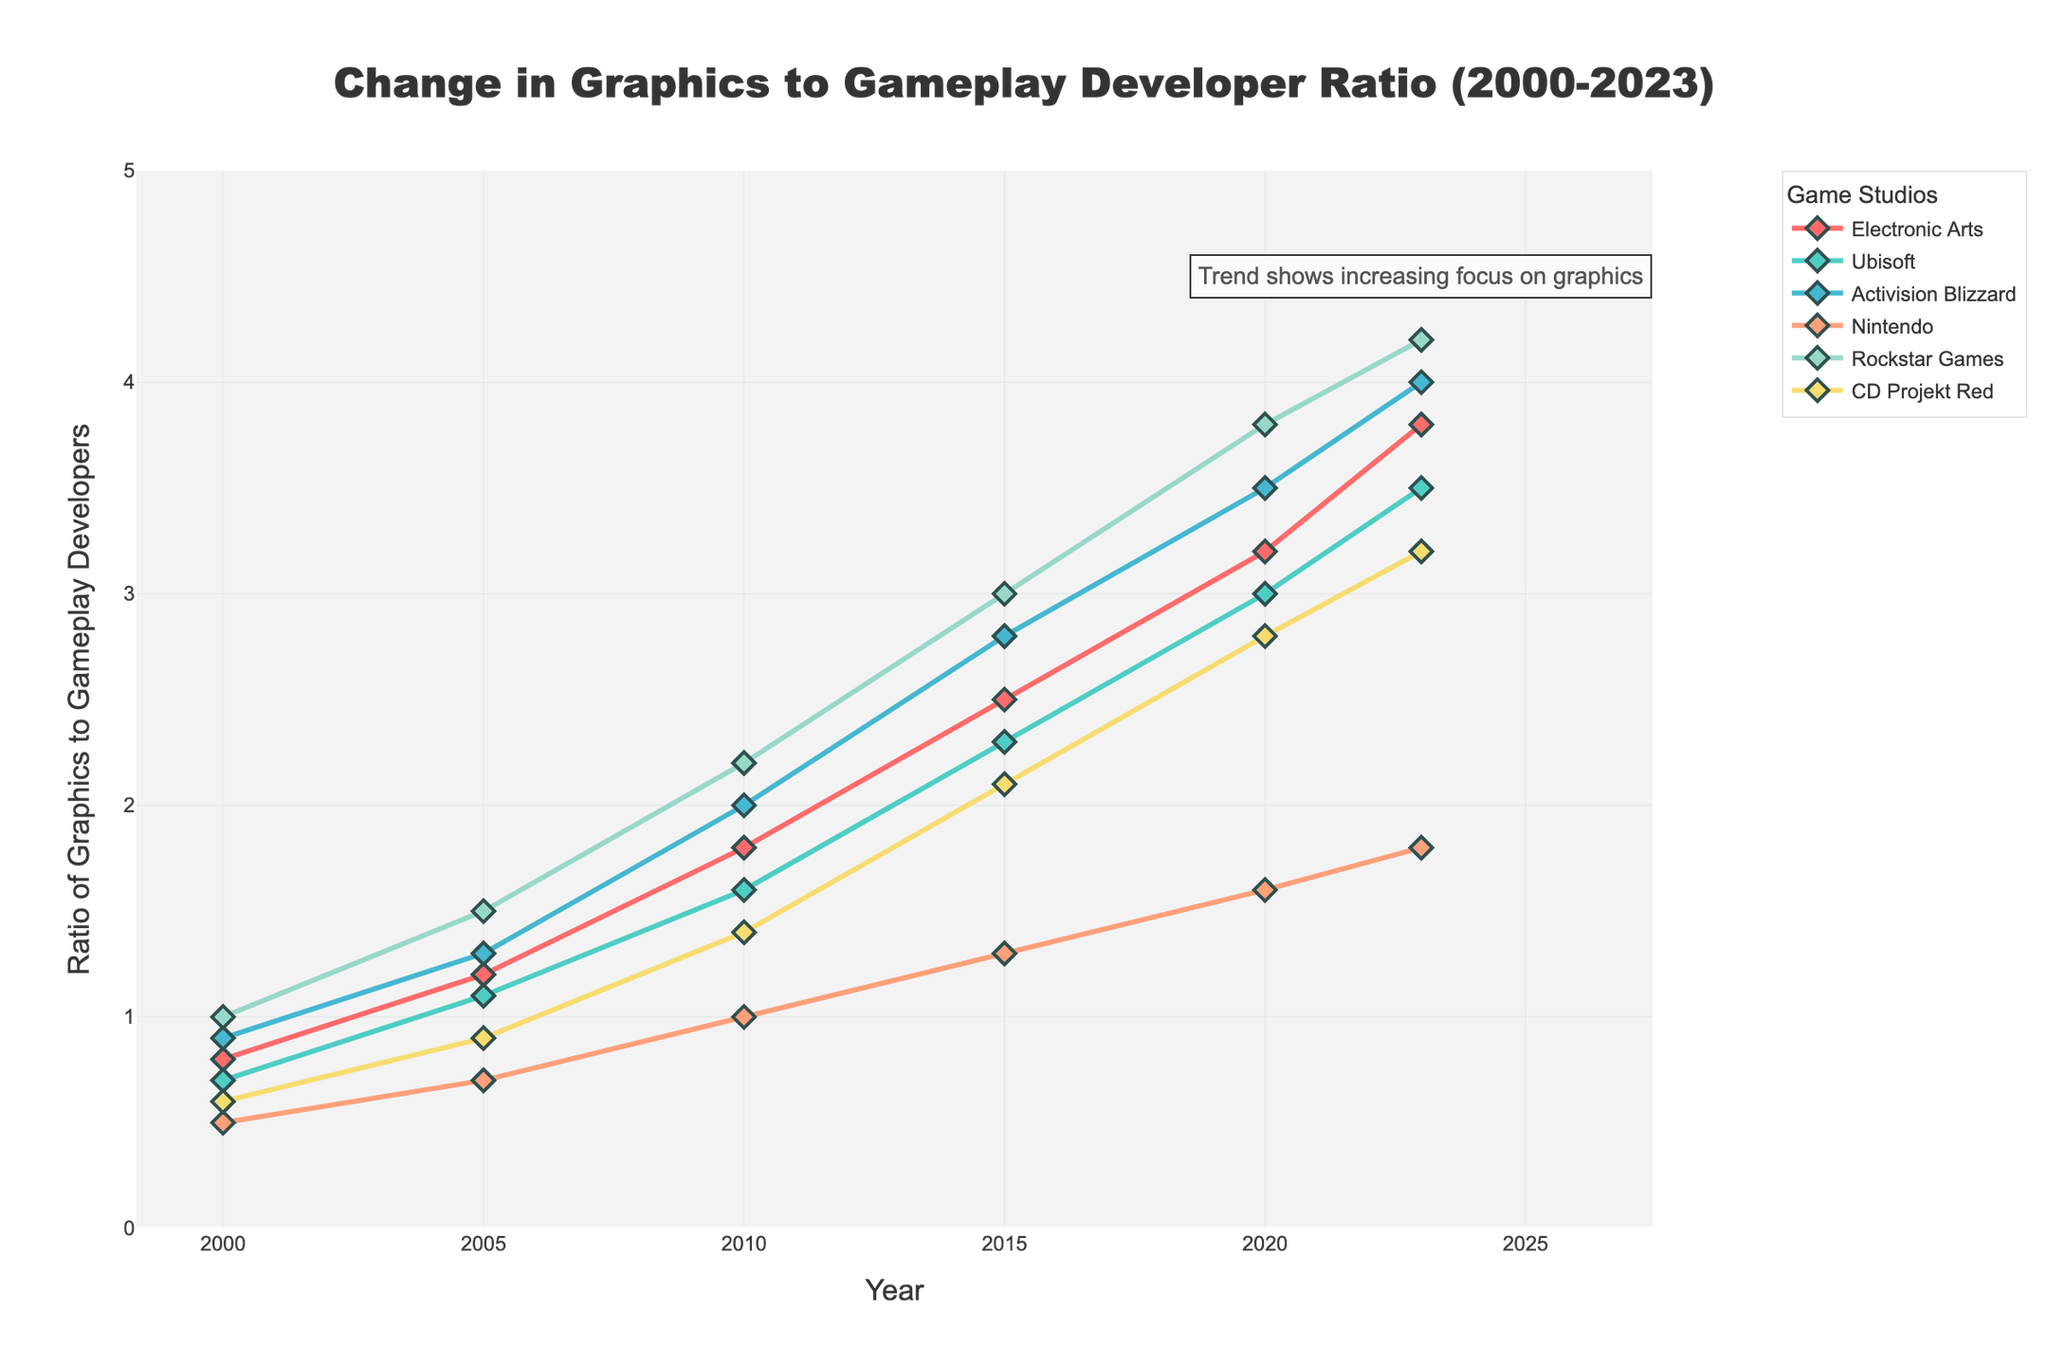What does the overall trend show about the ratio of graphics developers to gameplay programmers among all the game studios from 2000 to 2023? The overall trend indicates a steady increase in the ratio of graphics developers to gameplay programmers across all major game studios. Starting from relatively lower values in 2000, the ratios generally rise significantly over time, reaching the highest levels by 2023.
Answer: It shows a steady increase Which game studio had the highest ratio of graphics developers to gameplay programmers in 2023, and what was the ratio? By observing the topmost point in the year 2023, Rockstar Games had the highest ratio of graphics developers to gameplay programmers.
Answer: Rockstar Games; 4.2 How did Nintendo's ratio change from 2000 to 2023, and what does this reflect? By comparing the data points for Nintendo from 2000 (0.5) and 2023 (1.8), we see an increase of 1.3 in the ratio. This reflects a growing focus on graphics development over the 23 years.
Answer: Increased by 1.3 Between which two consecutive years did CD Projekt Red see the highest increase in its ratio of graphics developers to gameplay programmers? To identify this, we compare the differences between consecutive years: 2000-2005 (0.9-0.6=0.3), 2005-2010 (1.4-0.9=0.5), 2010-2015 (2.1-1.4=0.7), 2015-2020 (2.8-2.1=0.7), and 2020-2023 (3.2-2.8=0.4). The highest increase is between 2010 and 2015 and between 2015 and 2020, both with an increase of 0.7.
Answer: 2010-2015 and 2015-2020 Compare the ratio of graphics to gameplay developers for Ubisoft and Activision Blizzard in 2015 and indicate which company had the lower ratio. By looking at the data points for 2015, Ubisoft had a ratio of 2.3 and Activision Blizzard had a ratio of 2.8. Ubisoft had the lower ratio in 2015.
Answer: Ubisoft What can be inferred about the emphasis on graphics vs. gameplay in major game studios from the visual characteristics of the plot? The increasing trend lines for all studios and their upward trajectory visually indicate a growing emphasis on graphics over gameplay. The annotation also emphasizes this observation, stating, “Trend shows increasing focus on graphics.”
Answer: Growing emphasis on graphics If we average the ratio values from 2000 to 2023 for Electronic Arts, what is the average? The values for Electronic Arts from 2000 to 2023 are 0.8, 1.2, 1.8, 2.5, 3.2, and 3.8. Averaging these: (0.8 + 1.2 + 1.8 + 2.5 + 3.2 + 3.8)/6 = 2.217.
Answer: 2.217 Which company had the most significant increase from 2000 to 2023, and by how much did their ratio change? To determine this, calculate the difference for each company from 2000 to 2023. Electronic Arts (3.8-0.8=3), Ubisoft (3.5-0.7=2.8), Activision Blizzard (4-0.9=3.1), Nintendo (1.8-0.5=1.3), Rockstar Games (4.2-1=3.2), and CD Projekt Red (3.2-0.6=2.6). Rockstar Games had the most significant increase of 3.2.
Answer: Rockstar Games; 3.2 Using the plot, can you deduce which year had the most balanced ratio (closest to each other) for all companies? By visually estimating the plot curves, the year 2000 appears to have the most balanced ratios across all companies, with values ranging between 0.5 and 1.0.
Answer: 2000 